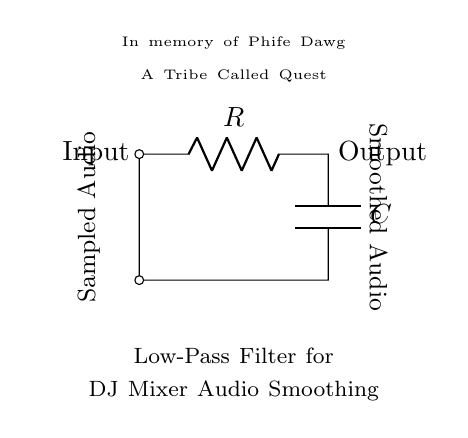What type of filter is this circuit? This circuit is a low-pass filter, as indicated by its configuration that allows low-frequency signals to pass through while attenuating higher frequencies. This is achieved with a resistor and capacitor in series with the input and output.
Answer: Low-pass filter What is the role of the resistor in the circuit? The resistor limits the amount of current flowing through the circuit, affecting the time constant of the filter along with the capacitor. This impacts how quickly the circuit can respond to changes in the input signal while smoothing out high-frequency noise.
Answer: Current limiting What does the capacitor do in this low-pass filter? The capacitor stores electrical energy and smooths out variations in the voltage over time. It charges and discharges in response to the input signal, allowing lower frequencies to pass while blocking higher frequencies as it creates a voltage divider effect.
Answer: Smoothing voltage What is the direction of current flow in this circuit? Current flows from the input side through the resistor first and then to the capacitor, finally exiting the circuit at the output. This flow enables the filtering process to occur.
Answer: Input to output How does the cutoff frequency of this low-pass filter depend on R and C? The cutoff frequency (the frequency at which the output voltage is reduced to approximately 70.7% of the input voltage) is determined by the values of the resistor and capacitor. It is calculated using the formula fc = 1/(2πRC), linking these two components directly to the filter's characteristics.
Answer: 1/(2πRC) What is indicated by the labels 'Input' and 'Output' in the circuit? 'Input' signifies where the sampled audio signal enters the circuit for processing, while 'Output' indicates the smoothed audio signal that exits the filter after processing. This differentiates between the unfiltered and the filtered signal.
Answer: Sampled audio and smoothed audio What element of the circuit is dedicated to Phife Dawg's memory? The circuit includes a text node stating "In memory of Phife Dawg" as a tribute, indicating a personal touch that honors the artist, blending personal sentiment with technical design in the circuit schematic.
Answer: Tribute message 